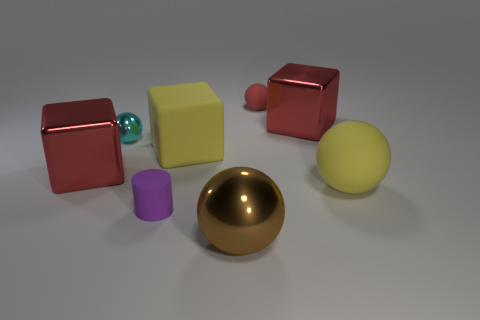Subtract 2 balls. How many balls are left? 2 Add 2 small purple cylinders. How many objects exist? 10 Subtract all cylinders. How many objects are left? 7 Add 3 large yellow shiny balls. How many large yellow shiny balls exist? 3 Subtract 0 brown cubes. How many objects are left? 8 Subtract all yellow objects. Subtract all tiny cyan balls. How many objects are left? 5 Add 3 big brown things. How many big brown things are left? 4 